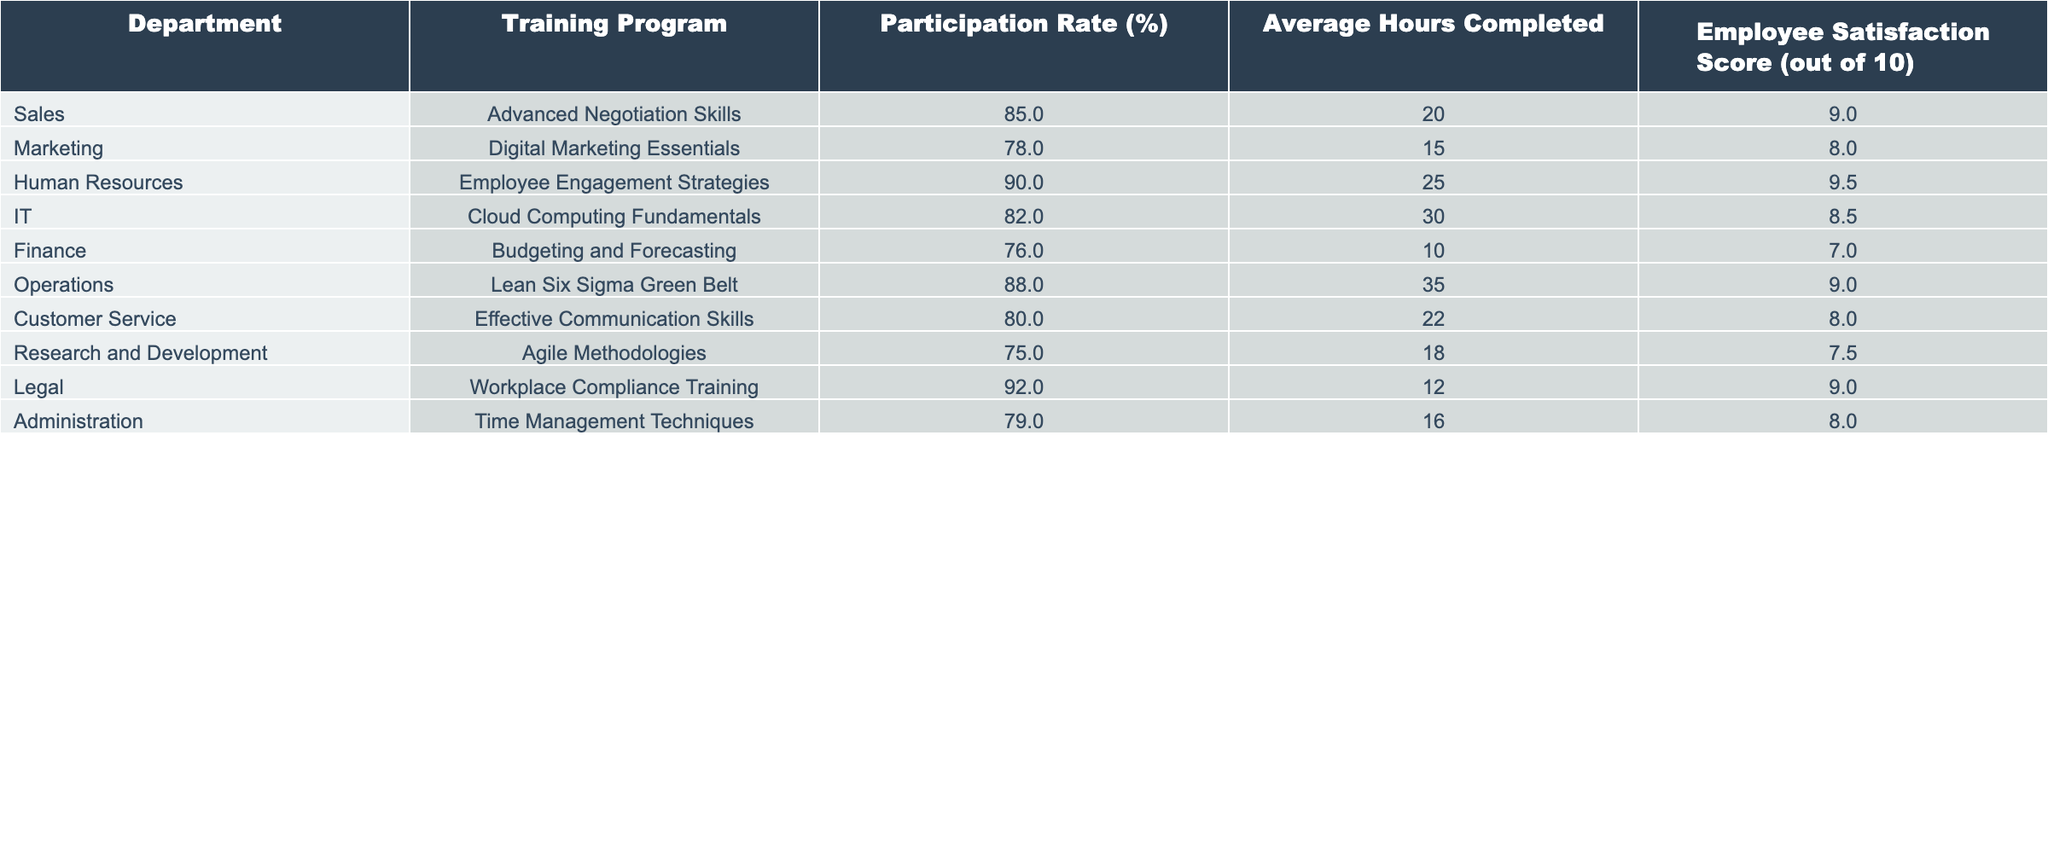What is the participation rate of the Human Resources department? The table shows that the participation rate for the Human Resources department is indicated in the "Participation Rate (%)" column, which states 90%.
Answer: 90% Which department had the highest employee satisfaction score? By examining the "Employee Satisfaction Score" column, the department with the highest score is Human Resources with a score of 9.5.
Answer: Human Resources What is the average participation rate across all departments? We sum all the participation rates: 85 + 78 + 90 + 82 + 76 + 88 + 80 + 75 + 92 + 79 =  834. There are 10 departments, so the average is 834/10 = 83.4%.
Answer: 83.4% Is there a department with a participation rate below 80%? Looking at the "Participation Rate (%)" column, we see that both Finance (76%) and Research and Development (75%) have rates below 80%.
Answer: Yes How many departments had a participation rate of 85% or higher? The departments with rates of 85% or higher are Sales (85%), Human Resources (90%), Operations (88%), and Legal (92%). There are 4 such departments.
Answer: 4 What is the difference in employee satisfaction scores between the Operations and Finance departments? The employee satisfaction score for Operations is 9, and for Finance, it is 7. Therefore, the difference is 9 - 7 = 2.
Answer: 2 Which training program had the lowest participation rate? The "Participation Rate (%)" column shows that the lowest participation rate is in Research and Development at 75%.
Answer: Agile Methodologies Which department completed the most average hours of training? By looking at the "Average Hours Completed" column, Operations completed the most hours at 35.
Answer: Operations What is the total average hours of training completed by departments with a participation rate above 80%? We first identify departments with rates above 80%, which are Sales, Human Resources, IT, Operations, and Legal. The hours are: 20 + 25 + 30 + 35 + 12 = 132 hours.
Answer: 132 hours Which department had the lowest employee satisfaction score? In reviewing the "Employee Satisfaction Score," Finance has the lowest score at 7.
Answer: Finance 